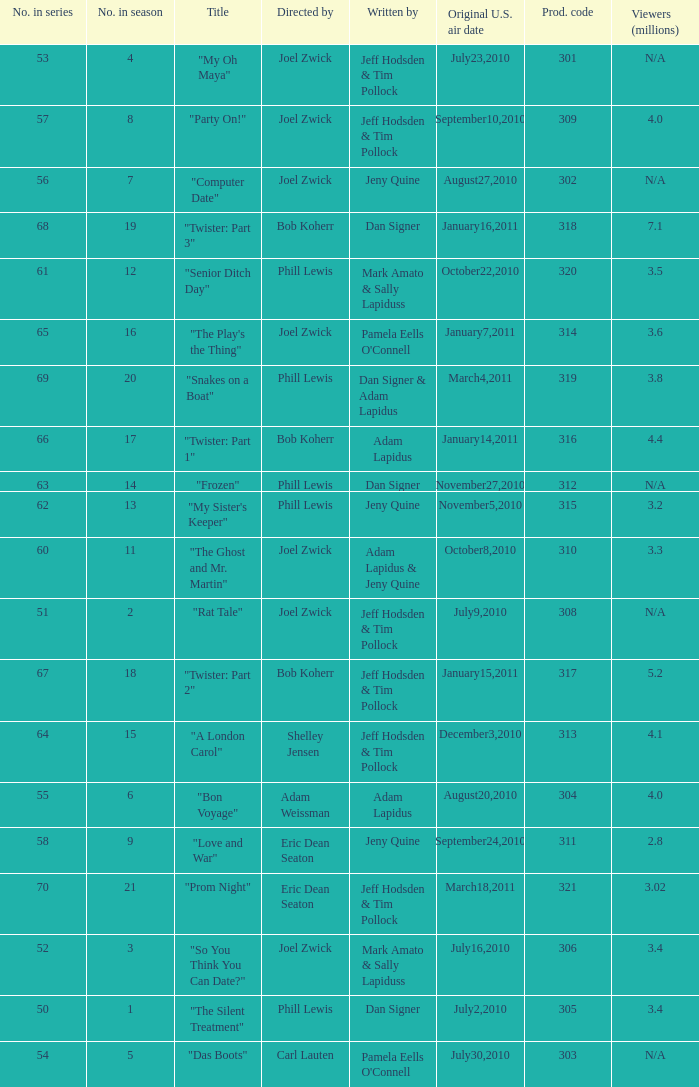How many million viewers watched episode 6? 4.0. 